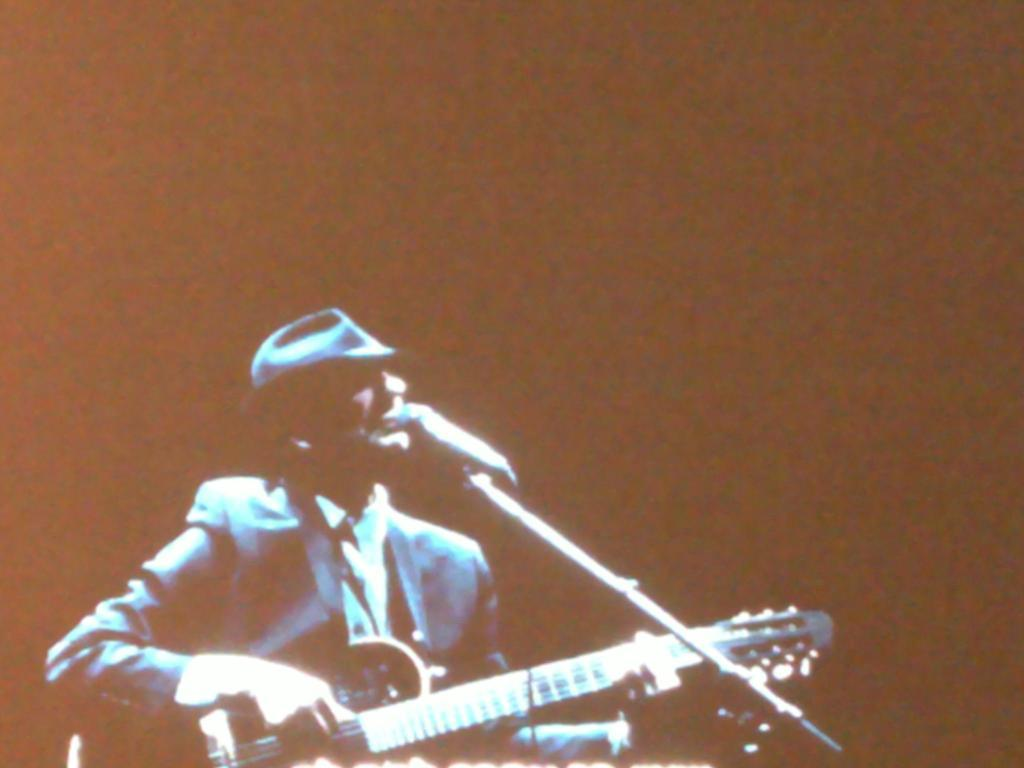What is the man in the image doing? The man is singing in the image. What is the man holding while singing? The man is holding a microphone in the image. What musical instrument is the man playing? The man is playing a guitar in the image. How many people are in the crowd watching the man play the guitar in the image? There is no crowd present in the image; it only features the man singing and playing a guitar. What type of feather is attached to the guitar in the image? There is no feather attached to the guitar in the image. 